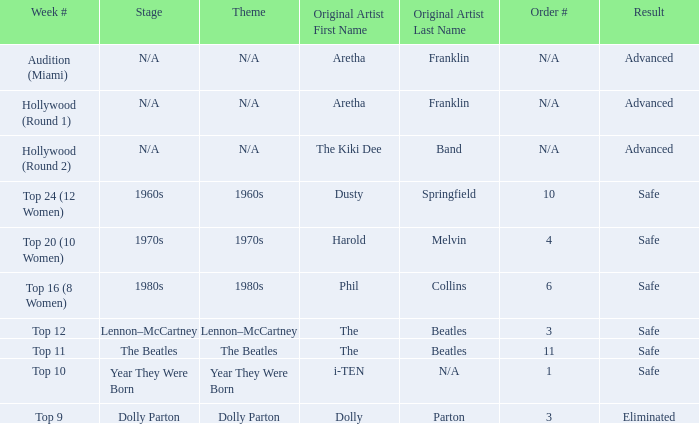What is the original artist of top 9 as the week number? Dolly Parton. 